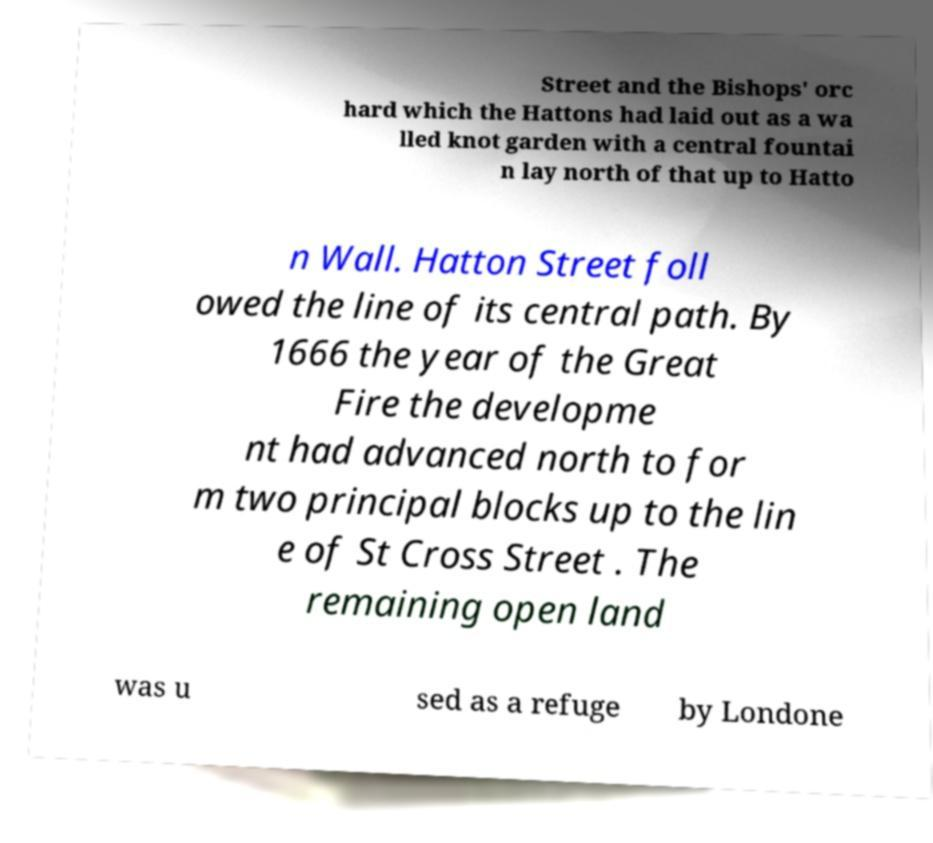Please identify and transcribe the text found in this image. Street and the Bishops' orc hard which the Hattons had laid out as a wa lled knot garden with a central fountai n lay north of that up to Hatto n Wall. Hatton Street foll owed the line of its central path. By 1666 the year of the Great Fire the developme nt had advanced north to for m two principal blocks up to the lin e of St Cross Street . The remaining open land was u sed as a refuge by Londone 